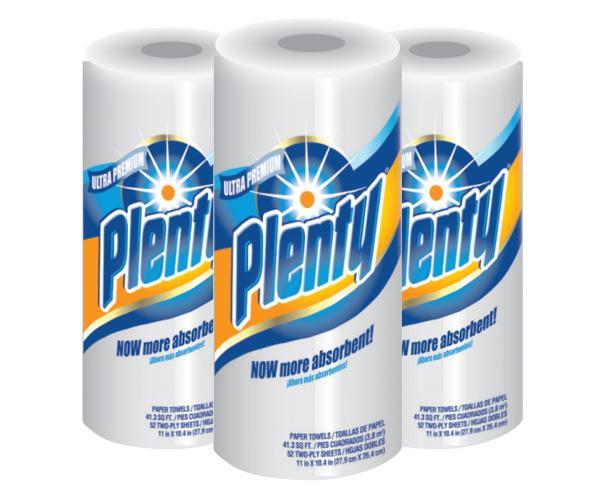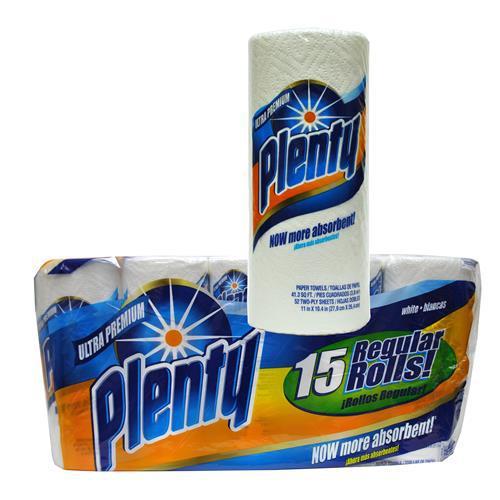The first image is the image on the left, the second image is the image on the right. Evaluate the accuracy of this statement regarding the images: "The paper towel package on the left features an image of three colored concentric rings, and the package on the right features a sunburst image.". Is it true? Answer yes or no. No. The first image is the image on the left, the second image is the image on the right. Considering the images on both sides, is "Two packages of the same brand of multiple rolls of paper towels are shown, the smaller package with least two rolls, and the larger package at least twice as large as the smaller one." valid? Answer yes or no. No. 